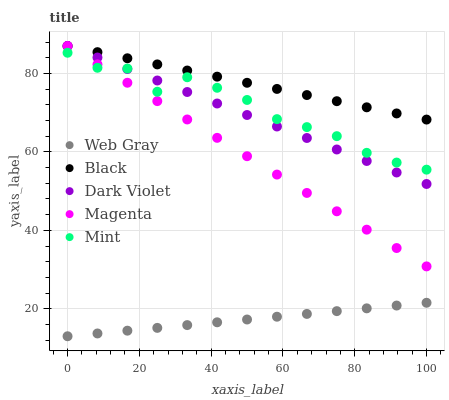Does Web Gray have the minimum area under the curve?
Answer yes or no. Yes. Does Black have the maximum area under the curve?
Answer yes or no. Yes. Does Magenta have the minimum area under the curve?
Answer yes or no. No. Does Magenta have the maximum area under the curve?
Answer yes or no. No. Is Web Gray the smoothest?
Answer yes or no. Yes. Is Mint the roughest?
Answer yes or no. Yes. Is Magenta the smoothest?
Answer yes or no. No. Is Magenta the roughest?
Answer yes or no. No. Does Web Gray have the lowest value?
Answer yes or no. Yes. Does Magenta have the lowest value?
Answer yes or no. No. Does Dark Violet have the highest value?
Answer yes or no. Yes. Does Web Gray have the highest value?
Answer yes or no. No. Is Web Gray less than Black?
Answer yes or no. Yes. Is Magenta greater than Web Gray?
Answer yes or no. Yes. Does Magenta intersect Dark Violet?
Answer yes or no. Yes. Is Magenta less than Dark Violet?
Answer yes or no. No. Is Magenta greater than Dark Violet?
Answer yes or no. No. Does Web Gray intersect Black?
Answer yes or no. No. 